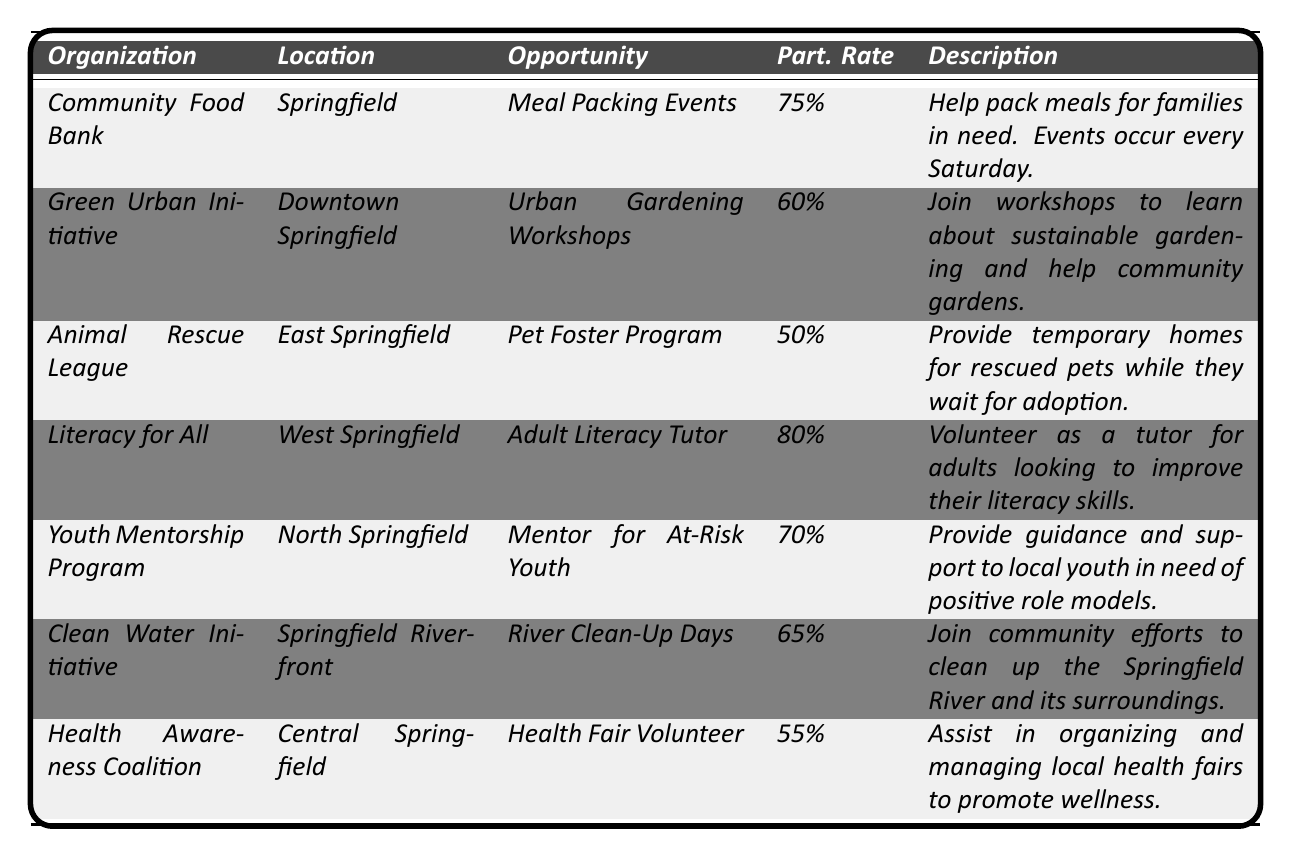What is the highest participation rate among the volunteer opportunities? The table shows various participation rates under the "Part. Rate" column. The highest listed rate is for "Adult Literacy Tutor" at 80%.
Answer: 80% Which organization offers a volunteer opportunity with a participation rate of 50%? By looking at the "Part. Rate" column, "Animal Rescue League" has a participation rate of 50%.
Answer: Animal Rescue League How many organizations have a participation rate of 60% or higher? The participation rates of 75%, 80%, 70%, and 65% are all 60% or higher. Counting the corresponding organizations, there are four: "Community Food Bank," "Literacy for All," "Youth Mentorship Program," and "Clean Water Initiative."
Answer: 4 Is there a volunteer opportunity related to animal welfare? The table lists "Pet Foster Program" under the "Animal Rescue League," which focuses on animal welfare by providing temporary homes for rescued pets.
Answer: Yes What is the average participation rate of all volunteer opportunities listed? To find the average, add all the participation rates: (75 + 60 + 50 + 80 + 70 + 65 + 55) = 455. There are 7 organizations, so the average is 455/7 ≈ 65.71%.
Answer: Approximately 65.71% Which organization's opportunity focuses on health awareness? "Health Fair Volunteer" is the opportunity that focuses on health awareness, provided by the "Health Awareness Coalition."
Answer: Health Awareness Coalition What is the difference in participation rates between the highest and lowest opportunities? The highest participation rate is 80% for "Literacy for All" and the lowest is 50% for "Animal Rescue League." The difference is 80% - 50% = 30%.
Answer: 30% Are all volunteer opportunities located in Springfield? The organizations are located in various parts of Springfield, including specific areas like Downtown Springfield, East Springfield, and North Springfield. Therefore, not all are strictly in Springfield without additional qualifiers.
Answer: No Which organization is located in North Springfield? The "Youth Mentorship Program" is listed in the North Springfield location.
Answer: Youth Mentorship Program What percentage of volunteer opportunities fall below a 60% participation rate? The opportunities with participation rates below 60% are "Animal Rescue League" at 50% and "Health Awareness Coalition" at 55%. That makes 2 out of 7, so (2/7) x 100 = 28.57%.
Answer: Approximately 28.57% 